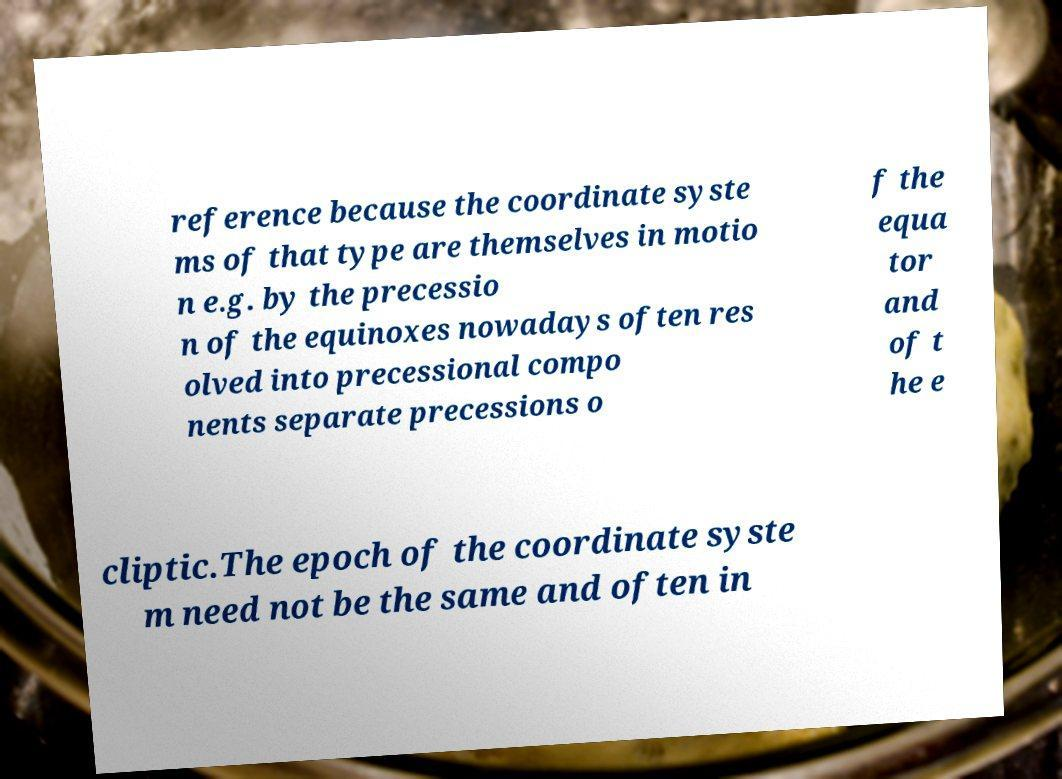I need the written content from this picture converted into text. Can you do that? reference because the coordinate syste ms of that type are themselves in motio n e.g. by the precessio n of the equinoxes nowadays often res olved into precessional compo nents separate precessions o f the equa tor and of t he e cliptic.The epoch of the coordinate syste m need not be the same and often in 